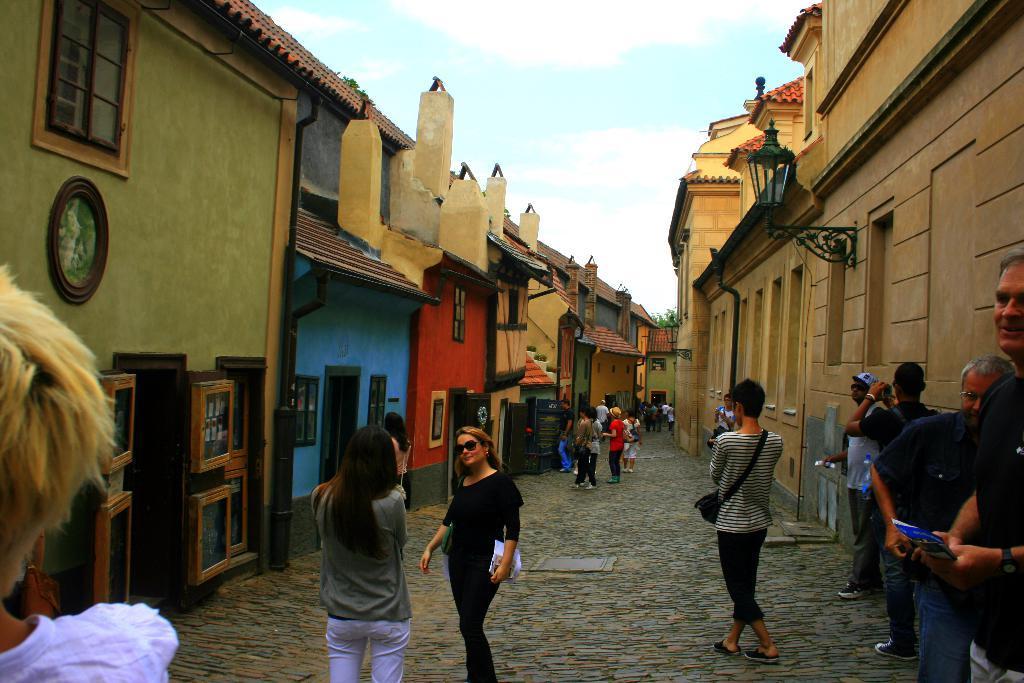In one or two sentences, can you explain what this image depicts? In this picture there are people on path and we can see buildings, boards, lights, windows and objects. In the background of the image we can see leaves and sky. 